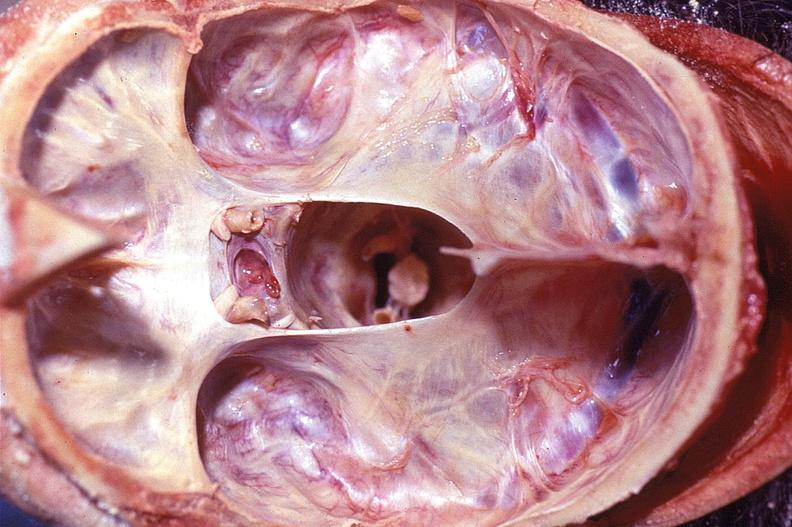s nervous present?
Answer the question using a single word or phrase. Yes 